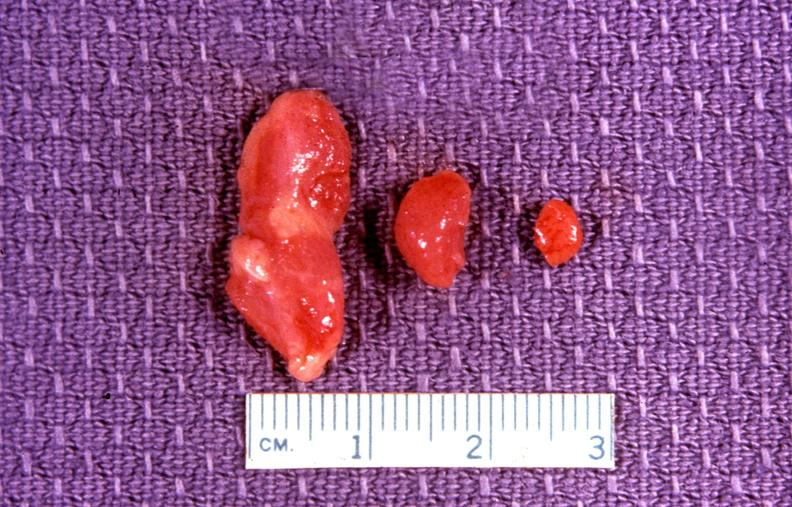s this image shows of smooth muscle cell with lipid in sarcoplasm and lipid present?
Answer the question using a single word or phrase. No 